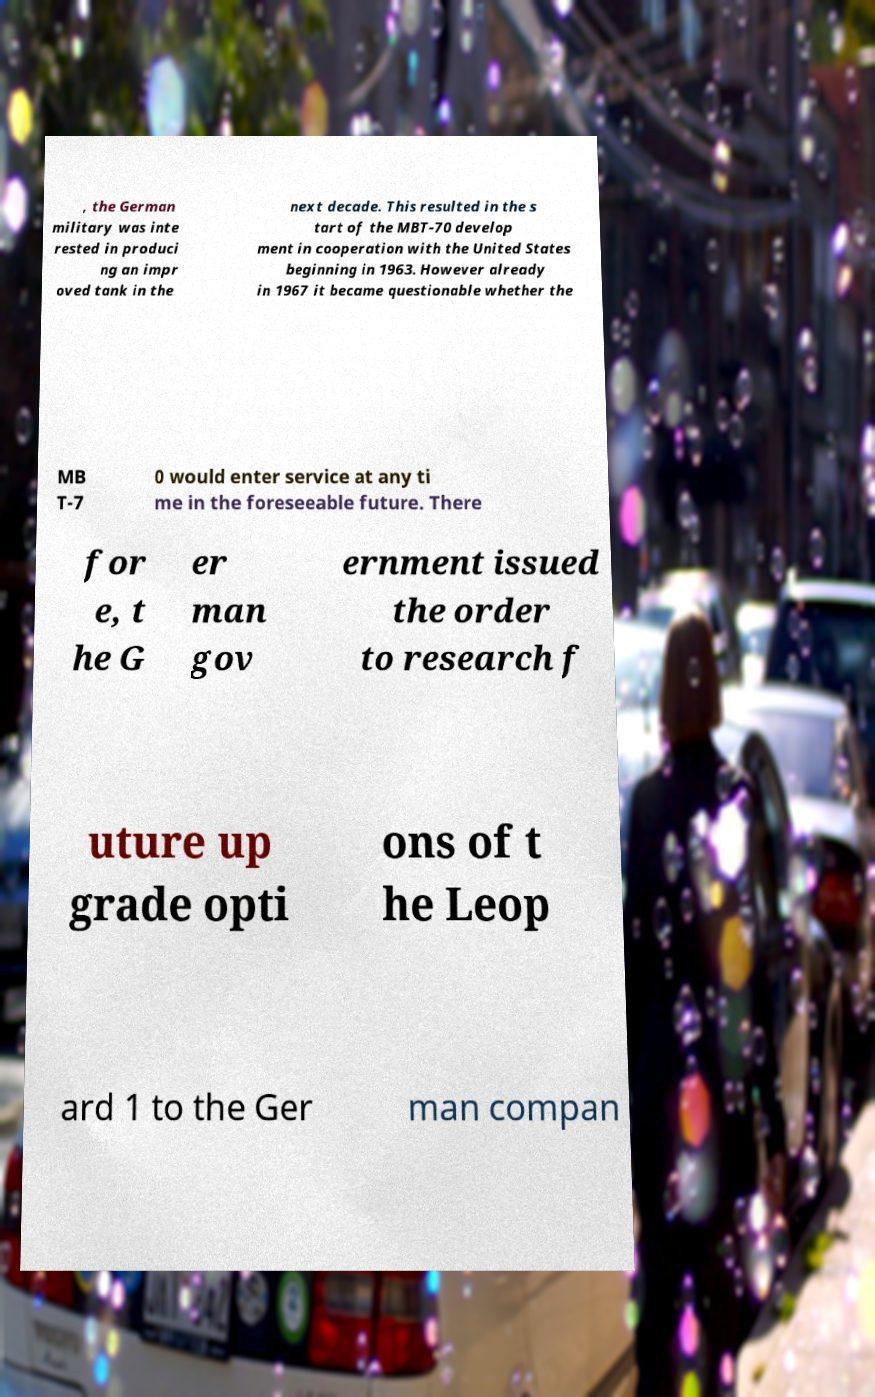Can you accurately transcribe the text from the provided image for me? , the German military was inte rested in produci ng an impr oved tank in the next decade. This resulted in the s tart of the MBT-70 develop ment in cooperation with the United States beginning in 1963. However already in 1967 it became questionable whether the MB T-7 0 would enter service at any ti me in the foreseeable future. There for e, t he G er man gov ernment issued the order to research f uture up grade opti ons of t he Leop ard 1 to the Ger man compan 